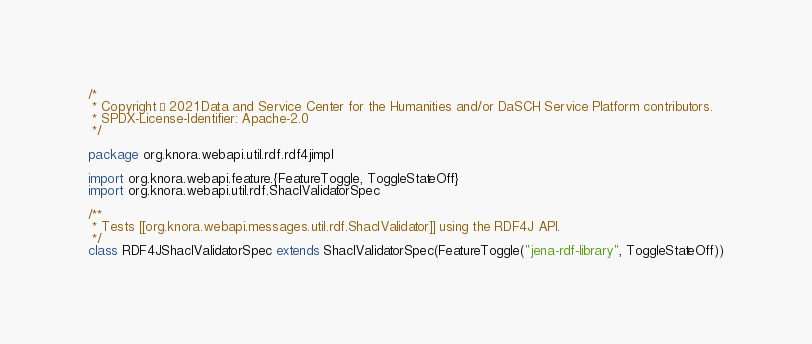<code> <loc_0><loc_0><loc_500><loc_500><_Scala_>/*
 * Copyright © 2021 Data and Service Center for the Humanities and/or DaSCH Service Platform contributors.
 * SPDX-License-Identifier: Apache-2.0
 */

package org.knora.webapi.util.rdf.rdf4jimpl

import org.knora.webapi.feature.{FeatureToggle, ToggleStateOff}
import org.knora.webapi.util.rdf.ShaclValidatorSpec

/**
 * Tests [[org.knora.webapi.messages.util.rdf.ShaclValidator]] using the RDF4J API.
 */
class RDF4JShaclValidatorSpec extends ShaclValidatorSpec(FeatureToggle("jena-rdf-library", ToggleStateOff))
</code> 